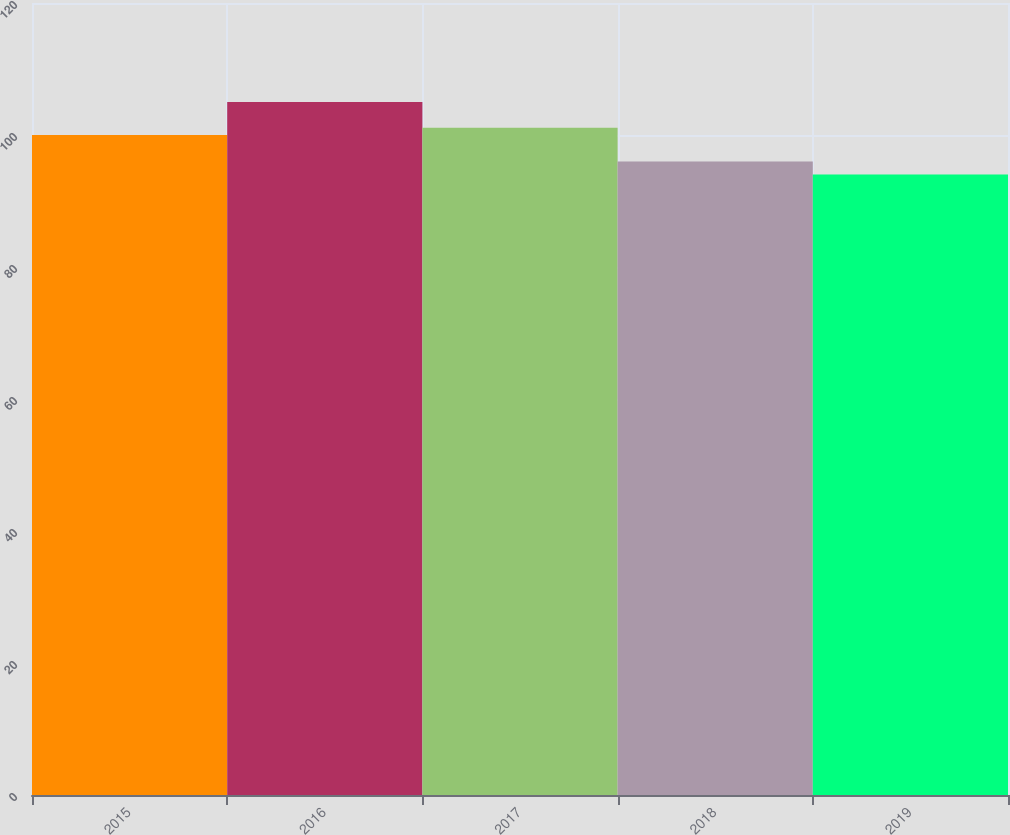<chart> <loc_0><loc_0><loc_500><loc_500><bar_chart><fcel>2015<fcel>2016<fcel>2017<fcel>2018<fcel>2019<nl><fcel>100<fcel>105<fcel>101.1<fcel>96<fcel>94<nl></chart> 